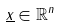<formula> <loc_0><loc_0><loc_500><loc_500>\underline { x } \in \mathbb { R } ^ { n }</formula> 